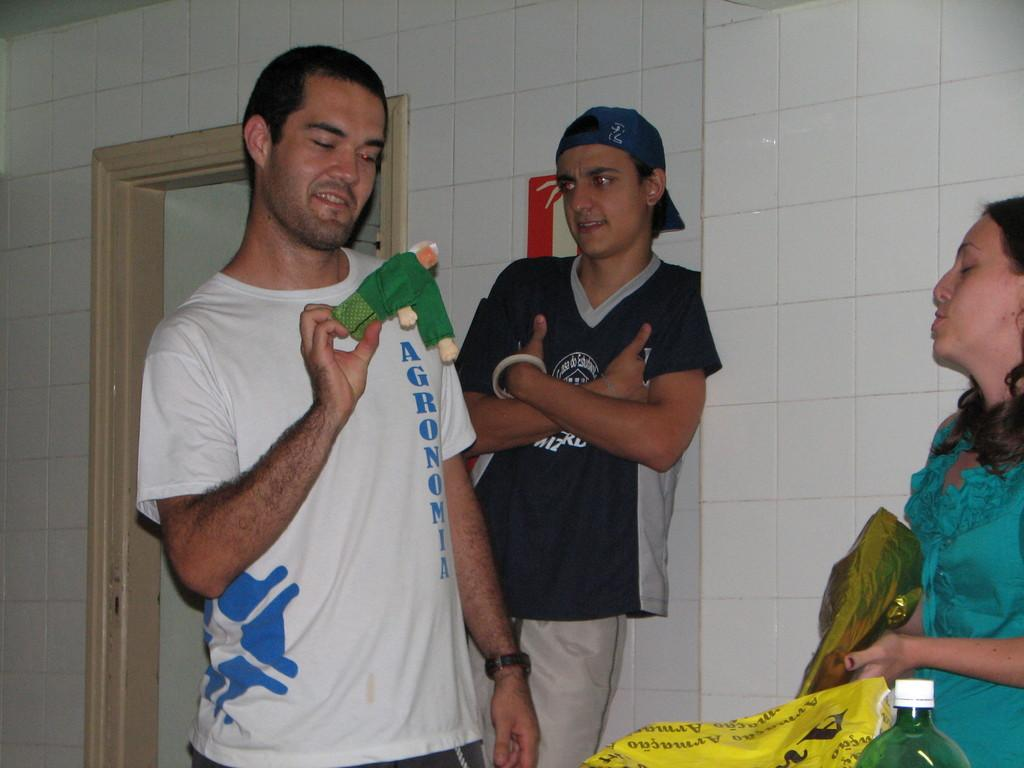What is the gender of the person standing on the left side of the image? The person standing on the left side of the image is a man. What is the man wearing in the image? The man is wearing a white t-shirt. What is the position of the person in the middle of the image? There is a person leaning against a wall in the middle of the image. What is the woman wearing on the right side of the image? The woman is wearing a green dress. What type of rod can be seen causing the woman to start dancing in the image? There is no rod or dancing depicted in the image; it features a man, a person leaning against a wall, and a woman in specific positions and clothing. 